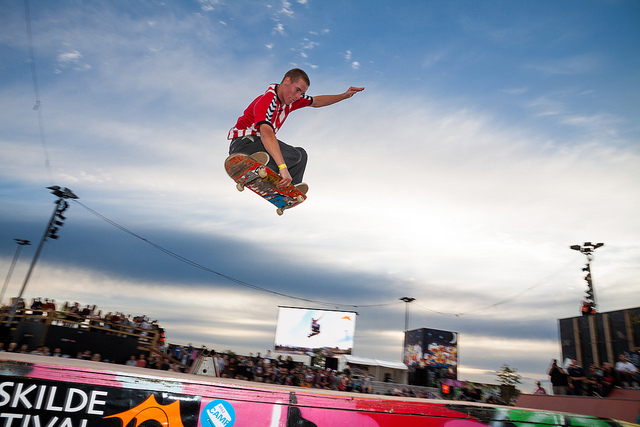How would you describe the atmosphere at the event where the skateboarder is performing his trick? The event appears to be lively and thrilling, with a sizable crowd gathered to watch the skateboarders. The open sky suggests that it's an outdoor event, possibly during late afternoon or early evening given the soft lighting. It seems to be a professional or semi-professional skateboarding event, given the large ramp, banners, and the presence of both spectators and photographers capturing the moment. 